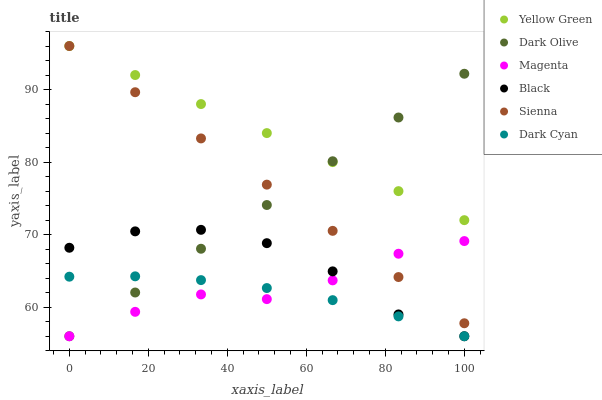Does Dark Cyan have the minimum area under the curve?
Answer yes or no. Yes. Does Yellow Green have the maximum area under the curve?
Answer yes or no. Yes. Does Dark Olive have the minimum area under the curve?
Answer yes or no. No. Does Dark Olive have the maximum area under the curve?
Answer yes or no. No. Is Sienna the smoothest?
Answer yes or no. Yes. Is Black the roughest?
Answer yes or no. Yes. Is Dark Olive the smoothest?
Answer yes or no. No. Is Dark Olive the roughest?
Answer yes or no. No. Does Dark Olive have the lowest value?
Answer yes or no. Yes. Does Sienna have the lowest value?
Answer yes or no. No. Does Sienna have the highest value?
Answer yes or no. Yes. Does Dark Olive have the highest value?
Answer yes or no. No. Is Black less than Yellow Green?
Answer yes or no. Yes. Is Yellow Green greater than Black?
Answer yes or no. Yes. Does Black intersect Dark Olive?
Answer yes or no. Yes. Is Black less than Dark Olive?
Answer yes or no. No. Is Black greater than Dark Olive?
Answer yes or no. No. Does Black intersect Yellow Green?
Answer yes or no. No. 